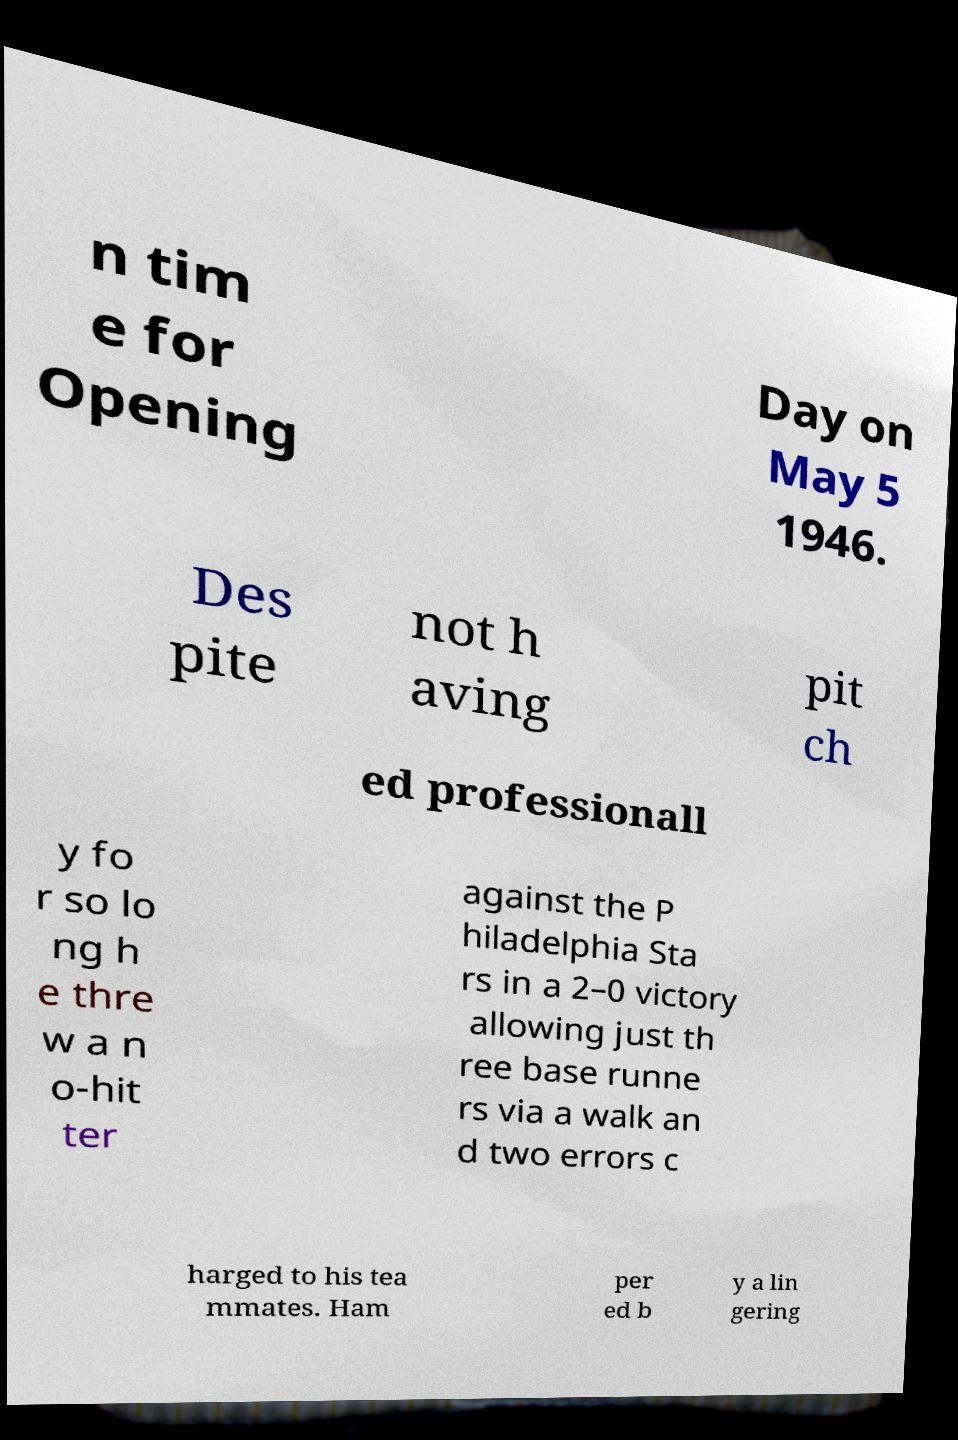Can you read and provide the text displayed in the image?This photo seems to have some interesting text. Can you extract and type it out for me? n tim e for Opening Day on May 5 1946. Des pite not h aving pit ch ed professionall y fo r so lo ng h e thre w a n o-hit ter against the P hiladelphia Sta rs in a 2–0 victory allowing just th ree base runne rs via a walk an d two errors c harged to his tea mmates. Ham per ed b y a lin gering 